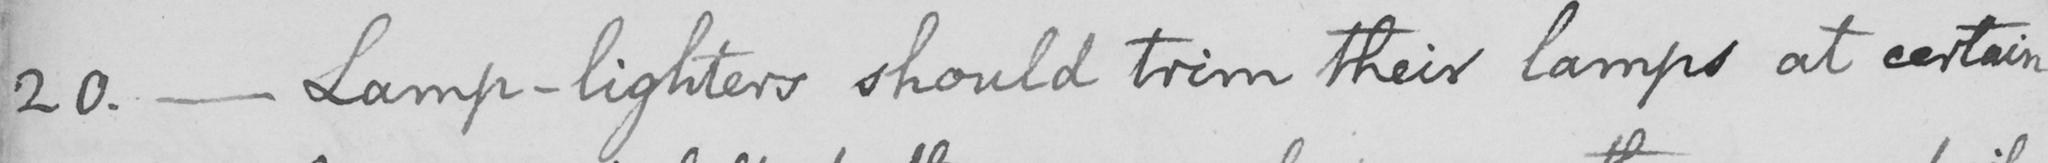What does this handwritten line say? 20 .  _  Lamp-lighters should trim their lamps at certain 